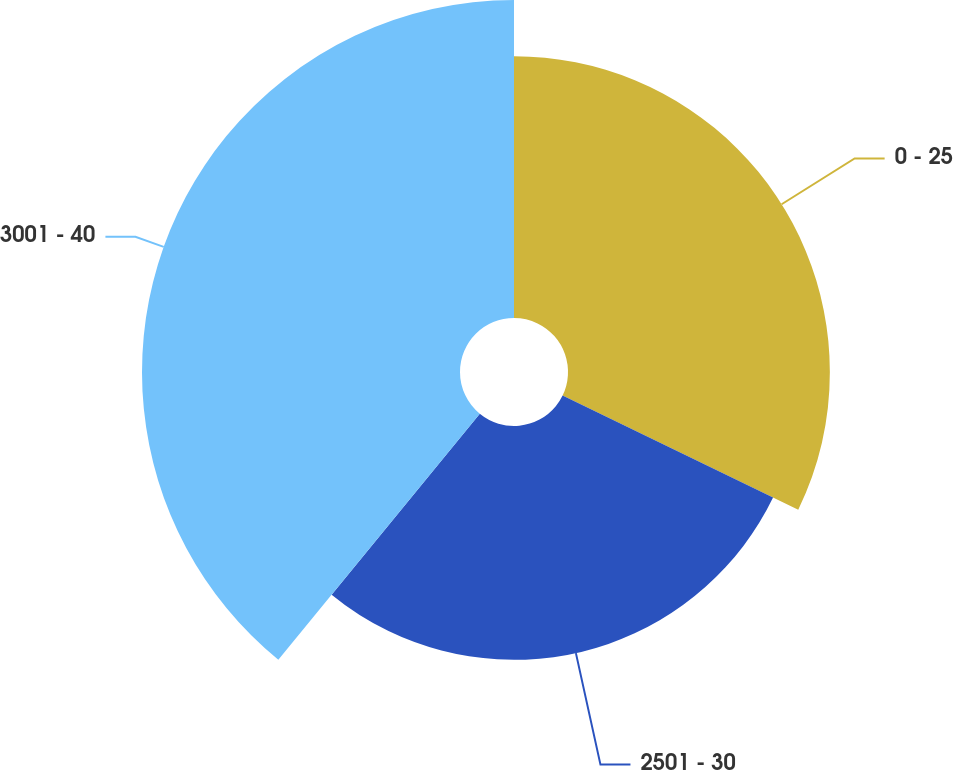Convert chart to OTSL. <chart><loc_0><loc_0><loc_500><loc_500><pie_chart><fcel>0 - 25<fcel>2501 - 30<fcel>3001 - 40<nl><fcel>32.18%<fcel>28.74%<fcel>39.08%<nl></chart> 